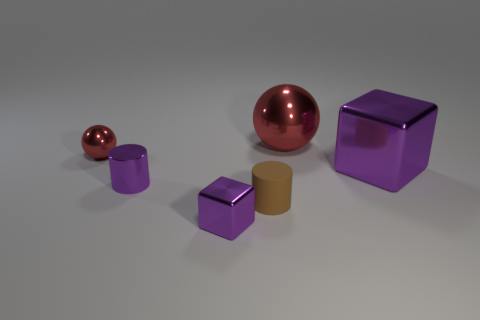The tiny brown thing behind the purple metallic cube that is to the left of the big thing right of the large red thing is made of what material?
Offer a terse response. Rubber. How many blocks are either yellow matte objects or large things?
Your answer should be very brief. 1. There is a red sphere to the left of the red thing that is right of the tiny purple block; what number of big metal objects are to the left of it?
Offer a very short reply. 0. Is the shape of the rubber thing the same as the big purple metal thing?
Offer a terse response. No. Do the large cube in front of the big red metal thing and the tiny cylinder right of the small metallic cube have the same material?
Offer a very short reply. No. How many objects are shiny things that are in front of the small red object or purple metal cubes that are to the left of the small matte thing?
Offer a terse response. 3. What number of big red metal balls are there?
Your answer should be compact. 1. Are there any blocks of the same size as the rubber cylinder?
Offer a very short reply. Yes. Does the small purple cylinder have the same material as the large ball behind the purple shiny cylinder?
Make the answer very short. Yes. There is a brown cylinder in front of the big metal sphere; what is it made of?
Provide a succinct answer. Rubber. 